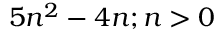Convert formula to latex. <formula><loc_0><loc_0><loc_500><loc_500>5 n ^ { 2 } - 4 n ; n > 0</formula> 